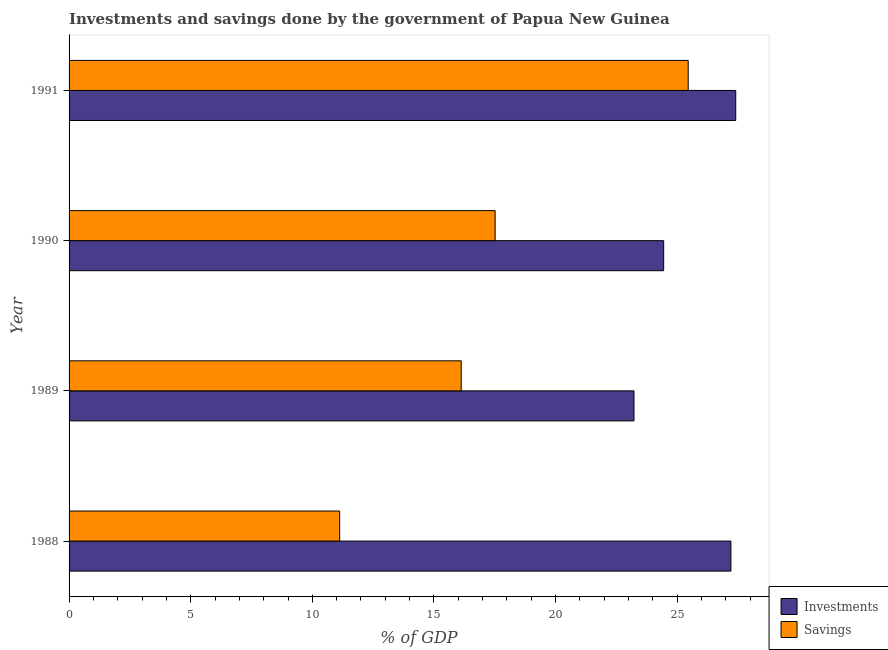How many different coloured bars are there?
Your answer should be compact. 2. Are the number of bars per tick equal to the number of legend labels?
Your response must be concise. Yes. Are the number of bars on each tick of the Y-axis equal?
Offer a very short reply. Yes. What is the label of the 4th group of bars from the top?
Offer a terse response. 1988. In how many cases, is the number of bars for a given year not equal to the number of legend labels?
Offer a terse response. 0. What is the savings of government in 1990?
Offer a very short reply. 17.51. Across all years, what is the maximum investments of government?
Provide a succinct answer. 27.4. Across all years, what is the minimum savings of government?
Provide a short and direct response. 11.12. In which year was the investments of government maximum?
Provide a succinct answer. 1991. In which year was the savings of government minimum?
Make the answer very short. 1988. What is the total savings of government in the graph?
Give a very brief answer. 70.21. What is the difference between the savings of government in 1988 and that in 1991?
Give a very brief answer. -14.33. What is the difference between the investments of government in 1988 and the savings of government in 1991?
Keep it short and to the point. 1.76. What is the average savings of government per year?
Give a very brief answer. 17.55. In the year 1990, what is the difference between the savings of government and investments of government?
Your answer should be compact. -6.93. What is the ratio of the investments of government in 1990 to that in 1991?
Provide a succinct answer. 0.89. Is the savings of government in 1989 less than that in 1991?
Make the answer very short. Yes. What is the difference between the highest and the second highest investments of government?
Provide a short and direct response. 0.2. What is the difference between the highest and the lowest savings of government?
Keep it short and to the point. 14.33. Is the sum of the savings of government in 1988 and 1991 greater than the maximum investments of government across all years?
Offer a very short reply. Yes. What does the 2nd bar from the top in 1991 represents?
Your answer should be very brief. Investments. What does the 2nd bar from the bottom in 1988 represents?
Ensure brevity in your answer.  Savings. How many years are there in the graph?
Make the answer very short. 4. Does the graph contain grids?
Give a very brief answer. No. Where does the legend appear in the graph?
Give a very brief answer. Bottom right. How many legend labels are there?
Offer a very short reply. 2. What is the title of the graph?
Give a very brief answer. Investments and savings done by the government of Papua New Guinea. Does "Passenger Transport Items" appear as one of the legend labels in the graph?
Your response must be concise. No. What is the label or title of the X-axis?
Ensure brevity in your answer.  % of GDP. What is the label or title of the Y-axis?
Your response must be concise. Year. What is the % of GDP in Investments in 1988?
Ensure brevity in your answer.  27.21. What is the % of GDP of Savings in 1988?
Offer a very short reply. 11.12. What is the % of GDP in Investments in 1989?
Ensure brevity in your answer.  23.22. What is the % of GDP in Savings in 1989?
Provide a succinct answer. 16.12. What is the % of GDP in Investments in 1990?
Give a very brief answer. 24.44. What is the % of GDP of Savings in 1990?
Provide a succinct answer. 17.51. What is the % of GDP in Investments in 1991?
Keep it short and to the point. 27.4. What is the % of GDP in Savings in 1991?
Provide a succinct answer. 25.45. Across all years, what is the maximum % of GDP in Investments?
Make the answer very short. 27.4. Across all years, what is the maximum % of GDP of Savings?
Your answer should be compact. 25.45. Across all years, what is the minimum % of GDP in Investments?
Provide a short and direct response. 23.22. Across all years, what is the minimum % of GDP of Savings?
Ensure brevity in your answer.  11.12. What is the total % of GDP of Investments in the graph?
Provide a succinct answer. 102.28. What is the total % of GDP in Savings in the graph?
Offer a very short reply. 70.21. What is the difference between the % of GDP in Investments in 1988 and that in 1989?
Provide a short and direct response. 3.98. What is the difference between the % of GDP of Savings in 1988 and that in 1989?
Offer a terse response. -5. What is the difference between the % of GDP of Investments in 1988 and that in 1990?
Your answer should be compact. 2.76. What is the difference between the % of GDP of Savings in 1988 and that in 1990?
Give a very brief answer. -6.39. What is the difference between the % of GDP in Investments in 1988 and that in 1991?
Provide a succinct answer. -0.2. What is the difference between the % of GDP of Savings in 1988 and that in 1991?
Offer a terse response. -14.33. What is the difference between the % of GDP of Investments in 1989 and that in 1990?
Provide a succinct answer. -1.22. What is the difference between the % of GDP of Savings in 1989 and that in 1990?
Your answer should be compact. -1.39. What is the difference between the % of GDP of Investments in 1989 and that in 1991?
Offer a terse response. -4.18. What is the difference between the % of GDP in Savings in 1989 and that in 1991?
Make the answer very short. -9.33. What is the difference between the % of GDP in Investments in 1990 and that in 1991?
Offer a very short reply. -2.96. What is the difference between the % of GDP of Savings in 1990 and that in 1991?
Your response must be concise. -7.94. What is the difference between the % of GDP in Investments in 1988 and the % of GDP in Savings in 1989?
Your response must be concise. 11.09. What is the difference between the % of GDP of Investments in 1988 and the % of GDP of Savings in 1990?
Provide a succinct answer. 9.69. What is the difference between the % of GDP of Investments in 1988 and the % of GDP of Savings in 1991?
Ensure brevity in your answer.  1.76. What is the difference between the % of GDP of Investments in 1989 and the % of GDP of Savings in 1990?
Your answer should be compact. 5.71. What is the difference between the % of GDP in Investments in 1989 and the % of GDP in Savings in 1991?
Make the answer very short. -2.23. What is the difference between the % of GDP of Investments in 1990 and the % of GDP of Savings in 1991?
Your response must be concise. -1.01. What is the average % of GDP of Investments per year?
Keep it short and to the point. 25.57. What is the average % of GDP in Savings per year?
Your response must be concise. 17.55. In the year 1988, what is the difference between the % of GDP of Investments and % of GDP of Savings?
Your response must be concise. 16.08. In the year 1989, what is the difference between the % of GDP in Investments and % of GDP in Savings?
Your response must be concise. 7.1. In the year 1990, what is the difference between the % of GDP of Investments and % of GDP of Savings?
Provide a short and direct response. 6.93. In the year 1991, what is the difference between the % of GDP in Investments and % of GDP in Savings?
Offer a terse response. 1.95. What is the ratio of the % of GDP in Investments in 1988 to that in 1989?
Your answer should be compact. 1.17. What is the ratio of the % of GDP in Savings in 1988 to that in 1989?
Make the answer very short. 0.69. What is the ratio of the % of GDP in Investments in 1988 to that in 1990?
Your answer should be very brief. 1.11. What is the ratio of the % of GDP in Savings in 1988 to that in 1990?
Give a very brief answer. 0.64. What is the ratio of the % of GDP in Savings in 1988 to that in 1991?
Your response must be concise. 0.44. What is the ratio of the % of GDP of Investments in 1989 to that in 1990?
Give a very brief answer. 0.95. What is the ratio of the % of GDP of Savings in 1989 to that in 1990?
Your answer should be very brief. 0.92. What is the ratio of the % of GDP of Investments in 1989 to that in 1991?
Provide a succinct answer. 0.85. What is the ratio of the % of GDP of Savings in 1989 to that in 1991?
Make the answer very short. 0.63. What is the ratio of the % of GDP of Investments in 1990 to that in 1991?
Offer a very short reply. 0.89. What is the ratio of the % of GDP in Savings in 1990 to that in 1991?
Your answer should be compact. 0.69. What is the difference between the highest and the second highest % of GDP of Investments?
Your answer should be compact. 0.2. What is the difference between the highest and the second highest % of GDP of Savings?
Give a very brief answer. 7.94. What is the difference between the highest and the lowest % of GDP of Investments?
Your answer should be compact. 4.18. What is the difference between the highest and the lowest % of GDP in Savings?
Make the answer very short. 14.33. 